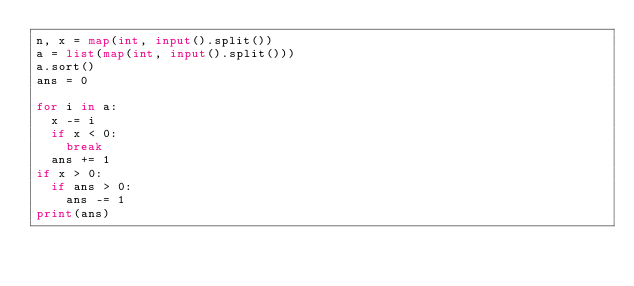<code> <loc_0><loc_0><loc_500><loc_500><_Python_>n, x = map(int, input().split())
a = list(map(int, input().split()))
a.sort()
ans = 0
 
for i in a:
  x -= i
  if x < 0:
    break
  ans += 1
if x > 0:
  if ans > 0:
    ans -= 1
print(ans)</code> 